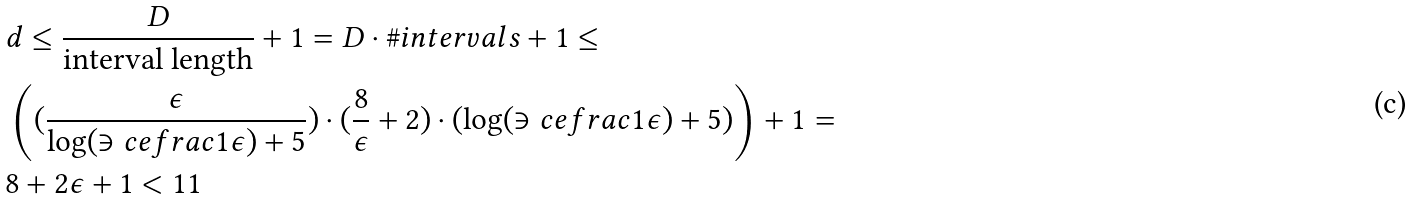Convert formula to latex. <formula><loc_0><loc_0><loc_500><loc_500>& d \leq \frac { D } { \text {interval length} } + 1 = D \cdot \# i n t e r v a l s + 1 \leq \\ & \left ( ( \frac { \epsilon } { \log ( \ni c e f r a c { 1 } { \epsilon } ) + 5 } ) \cdot ( \frac { 8 } { \epsilon } + 2 ) \cdot ( \log ( \ni c e f r a c { 1 } { \epsilon } ) + 5 ) \right ) + 1 = \\ & 8 + 2 \epsilon + 1 < 1 1</formula> 